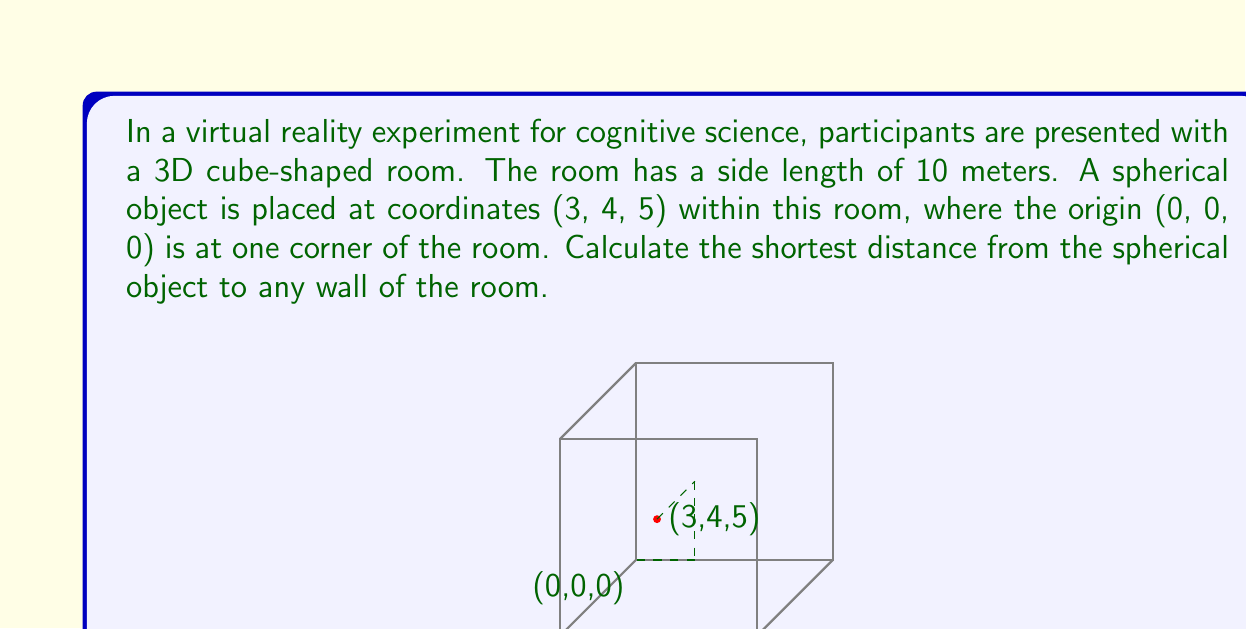What is the answer to this math problem? To solve this problem, we need to find the shortest distance from the point (3, 4, 5) to any of the six walls of the cube. The walls are represented by the planes x = 0, x = 10, y = 0, y = 10, z = 0, and z = 10.

The shortest distance from a point to a plane is always perpendicular to the plane. Therefore, we need to calculate the perpendicular distance from the point to each of the six planes and find the minimum.

1. Distance to x = 0 plane: 3
2. Distance to x = 10 plane: 10 - 3 = 7
3. Distance to y = 0 plane: 4
4. Distance to y = 10 plane: 10 - 4 = 6
5. Distance to z = 0 plane: 5
6. Distance to z = 10 plane: 10 - 5 = 5

The shortest distance is the minimum of these values: min(3, 7, 4, 6, 5, 5) = 3.

We can also derive this mathematically. The general formula for the distance d from a point (x₀, y₀, z₀) to a plane ax + by + cz + d = 0 is:

$$ d = \frac{|ax_0 + by_0 + cz_0 + d|}{\sqrt{a^2 + b^2 + c^2}} $$

For the x = 0 plane, the equation is simply x = 0 or 1x + 0y + 0z + 0 = 0. Substituting into the formula:

$$ d = \frac{|1(3) + 0(4) + 0(5) + 0|}{\sqrt{1^2 + 0^2 + 0^2}} = \frac{3}{1} = 3 $$

This confirms our earlier calculation and proves that the shortest distance is indeed 3 meters.
Answer: The shortest distance from the spherical object to any wall of the room is 3 meters. 